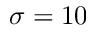<formula> <loc_0><loc_0><loc_500><loc_500>\sigma = 1 0</formula> 